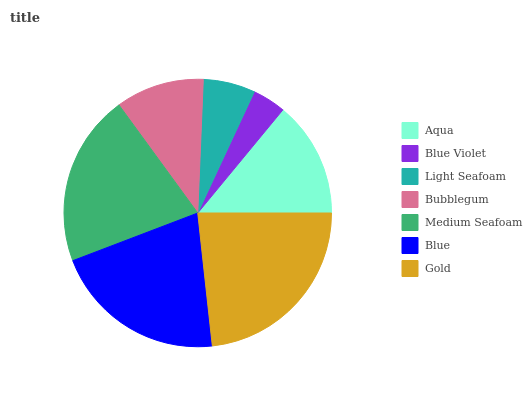Is Blue Violet the minimum?
Answer yes or no. Yes. Is Gold the maximum?
Answer yes or no. Yes. Is Light Seafoam the minimum?
Answer yes or no. No. Is Light Seafoam the maximum?
Answer yes or no. No. Is Light Seafoam greater than Blue Violet?
Answer yes or no. Yes. Is Blue Violet less than Light Seafoam?
Answer yes or no. Yes. Is Blue Violet greater than Light Seafoam?
Answer yes or no. No. Is Light Seafoam less than Blue Violet?
Answer yes or no. No. Is Aqua the high median?
Answer yes or no. Yes. Is Aqua the low median?
Answer yes or no. Yes. Is Gold the high median?
Answer yes or no. No. Is Blue the low median?
Answer yes or no. No. 